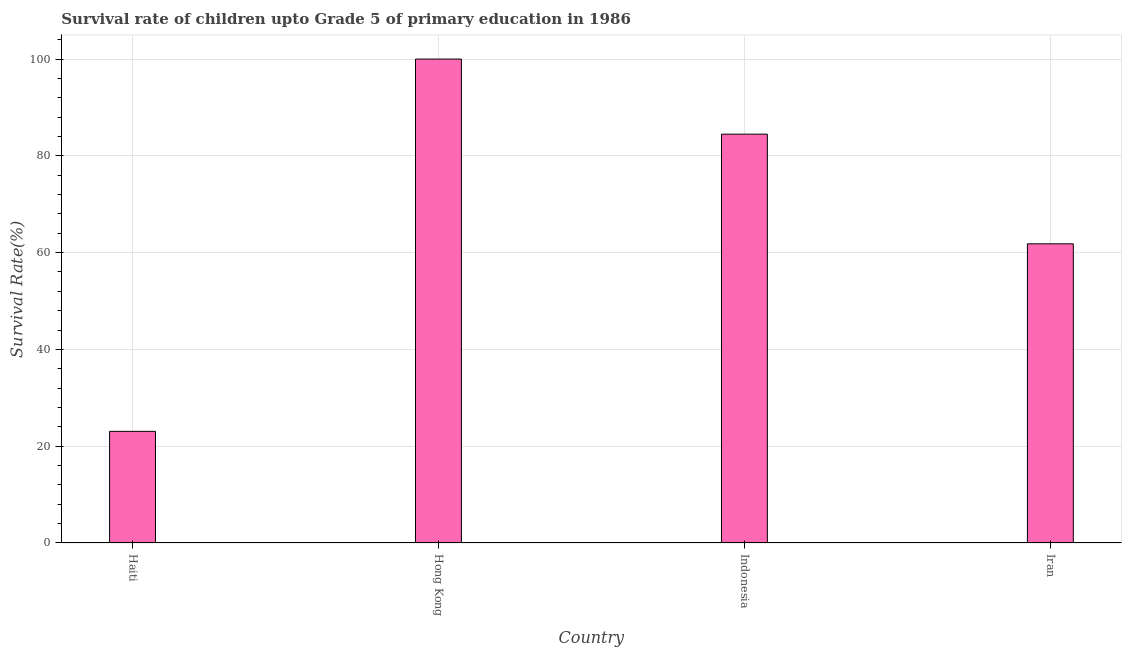Does the graph contain any zero values?
Your response must be concise. No. Does the graph contain grids?
Offer a very short reply. Yes. What is the title of the graph?
Provide a succinct answer. Survival rate of children upto Grade 5 of primary education in 1986 . What is the label or title of the Y-axis?
Your response must be concise. Survival Rate(%). What is the survival rate in Indonesia?
Offer a terse response. 84.48. Across all countries, what is the minimum survival rate?
Provide a short and direct response. 23.07. In which country was the survival rate maximum?
Your answer should be compact. Hong Kong. In which country was the survival rate minimum?
Offer a terse response. Haiti. What is the sum of the survival rate?
Ensure brevity in your answer.  269.37. What is the difference between the survival rate in Haiti and Indonesia?
Keep it short and to the point. -61.41. What is the average survival rate per country?
Ensure brevity in your answer.  67.34. What is the median survival rate?
Provide a succinct answer. 73.15. What is the ratio of the survival rate in Haiti to that in Indonesia?
Keep it short and to the point. 0.27. What is the difference between the highest and the second highest survival rate?
Ensure brevity in your answer.  15.52. What is the difference between the highest and the lowest survival rate?
Give a very brief answer. 76.93. How many countries are there in the graph?
Provide a succinct answer. 4. Are the values on the major ticks of Y-axis written in scientific E-notation?
Keep it short and to the point. No. What is the Survival Rate(%) in Haiti?
Ensure brevity in your answer.  23.07. What is the Survival Rate(%) in Hong Kong?
Keep it short and to the point. 100. What is the Survival Rate(%) in Indonesia?
Keep it short and to the point. 84.48. What is the Survival Rate(%) in Iran?
Make the answer very short. 61.82. What is the difference between the Survival Rate(%) in Haiti and Hong Kong?
Offer a very short reply. -76.93. What is the difference between the Survival Rate(%) in Haiti and Indonesia?
Your answer should be very brief. -61.41. What is the difference between the Survival Rate(%) in Haiti and Iran?
Ensure brevity in your answer.  -38.75. What is the difference between the Survival Rate(%) in Hong Kong and Indonesia?
Provide a succinct answer. 15.52. What is the difference between the Survival Rate(%) in Hong Kong and Iran?
Your response must be concise. 38.18. What is the difference between the Survival Rate(%) in Indonesia and Iran?
Your answer should be very brief. 22.66. What is the ratio of the Survival Rate(%) in Haiti to that in Hong Kong?
Your answer should be compact. 0.23. What is the ratio of the Survival Rate(%) in Haiti to that in Indonesia?
Ensure brevity in your answer.  0.27. What is the ratio of the Survival Rate(%) in Haiti to that in Iran?
Provide a succinct answer. 0.37. What is the ratio of the Survival Rate(%) in Hong Kong to that in Indonesia?
Provide a succinct answer. 1.18. What is the ratio of the Survival Rate(%) in Hong Kong to that in Iran?
Offer a terse response. 1.62. What is the ratio of the Survival Rate(%) in Indonesia to that in Iran?
Keep it short and to the point. 1.37. 